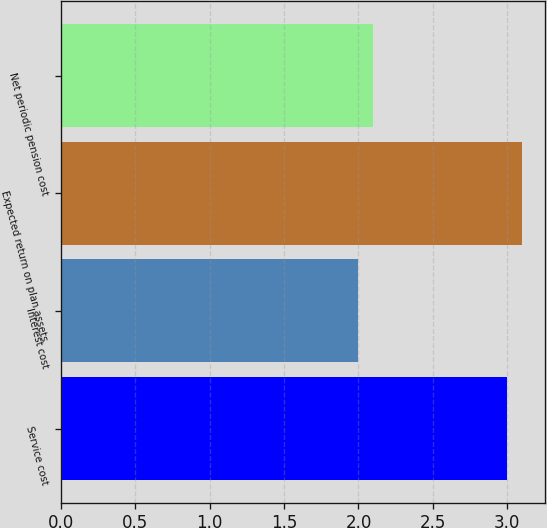Convert chart to OTSL. <chart><loc_0><loc_0><loc_500><loc_500><bar_chart><fcel>Service cost<fcel>Interest cost<fcel>Expected return on plan assets<fcel>Net periodic pension cost<nl><fcel>3<fcel>2<fcel>3.1<fcel>2.1<nl></chart> 